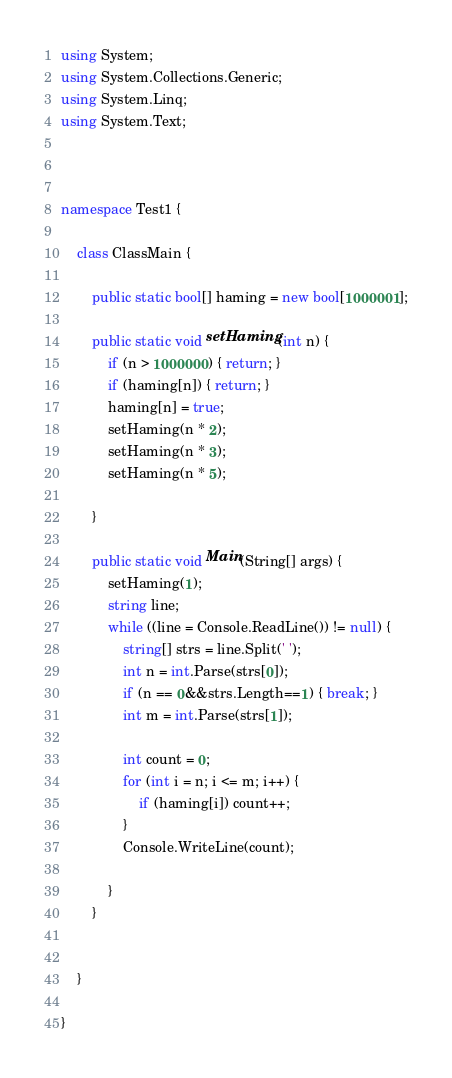<code> <loc_0><loc_0><loc_500><loc_500><_C#_>using System;
using System.Collections.Generic;
using System.Linq;
using System.Text;



namespace Test1 {

    class ClassMain {

        public static bool[] haming = new bool[1000001];

        public static void setHaming(int n) {
            if (n > 1000000) { return; }
            if (haming[n]) { return; }
            haming[n] = true;
            setHaming(n * 2);
            setHaming(n * 3);
            setHaming(n * 5);
        
        }
       
        public static void Main(String[] args) {
            setHaming(1);
            string line;
            while ((line = Console.ReadLine()) != null) {
                string[] strs = line.Split(' ');
                int n = int.Parse(strs[0]);
                if (n == 0&&strs.Length==1) { break; }
                int m = int.Parse(strs[1]);

                int count = 0;
                for (int i = n; i <= m; i++) {
                    if (haming[i]) count++;
                }
                Console.WriteLine(count);

            }
        }


    }

}</code> 